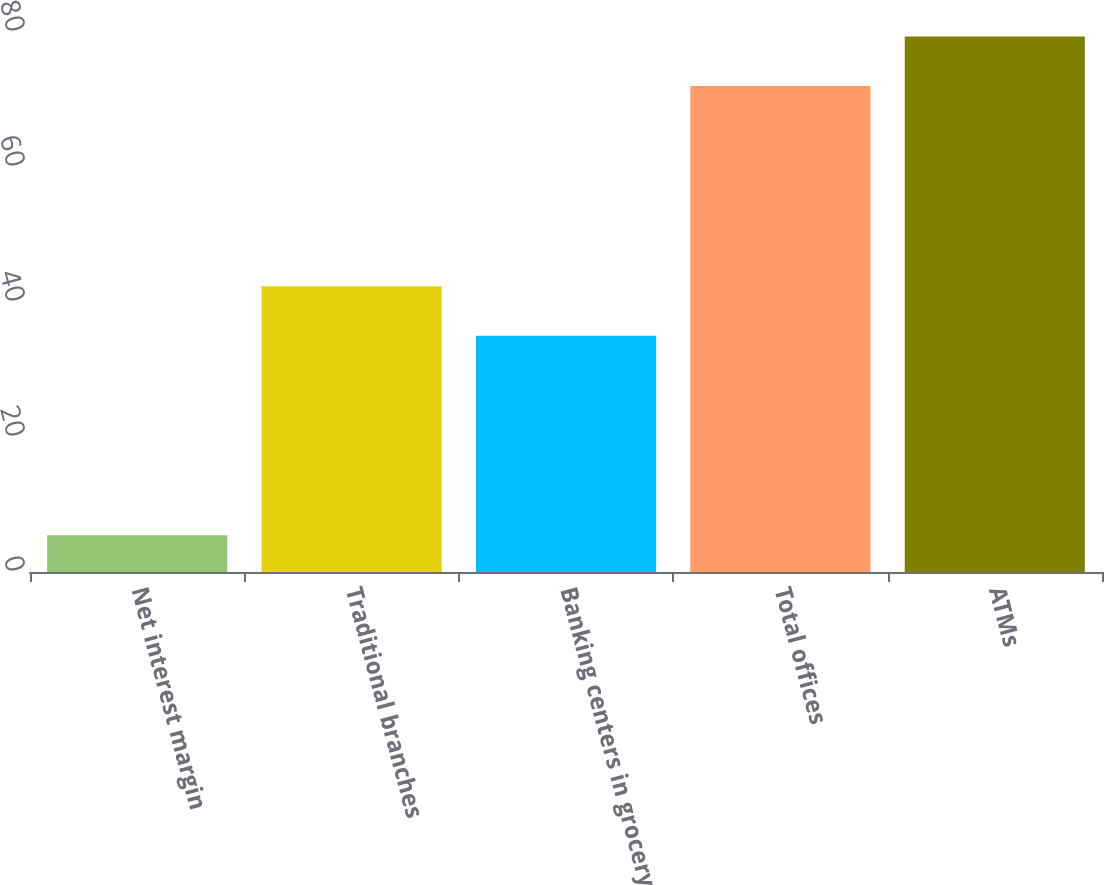<chart> <loc_0><loc_0><loc_500><loc_500><bar_chart><fcel>Net interest margin<fcel>Traditional branches<fcel>Banking centers in grocery<fcel>Total offices<fcel>ATMs<nl><fcel>5.46<fcel>42.35<fcel>35<fcel>72<fcel>79.35<nl></chart> 